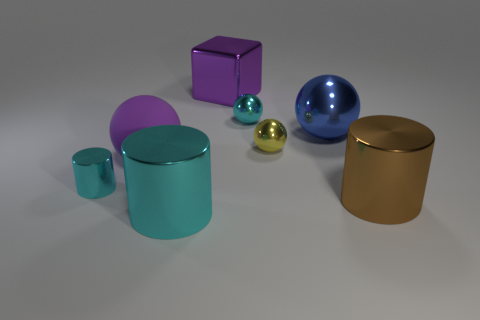Do the small metal sphere in front of the cyan ball and the object that is in front of the big brown metal object have the same color?
Make the answer very short. No. How many other objects are there of the same color as the tiny cylinder?
Your response must be concise. 2. How many blue objects are tiny metallic spheres or big spheres?
Keep it short and to the point. 1. There is a large brown object; is its shape the same as the shiny thing that is behind the tiny cyan metal sphere?
Ensure brevity in your answer.  No. What is the shape of the large blue object?
Ensure brevity in your answer.  Sphere. There is a brown object that is the same size as the purple metallic object; what is it made of?
Keep it short and to the point. Metal. Is there any other thing that has the same size as the blue shiny object?
Your answer should be very brief. Yes. How many objects are either green rubber cylinders or small cyan metallic objects that are in front of the big purple ball?
Keep it short and to the point. 1. There is a blue ball that is made of the same material as the purple block; what size is it?
Provide a succinct answer. Large. What shape is the small thing on the left side of the large block right of the large matte sphere?
Your answer should be compact. Cylinder. 